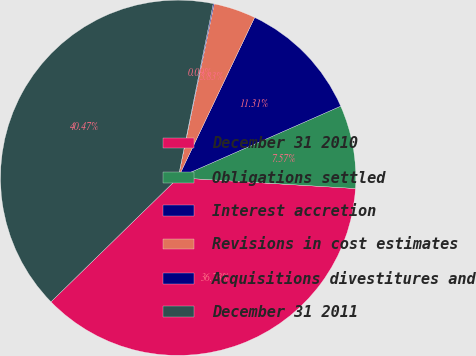<chart> <loc_0><loc_0><loc_500><loc_500><pie_chart><fcel>December 31 2010<fcel>Obligations settled<fcel>Interest accretion<fcel>Revisions in cost estimates<fcel>Acquisitions divestitures and<fcel>December 31 2011<nl><fcel>36.74%<fcel>7.57%<fcel>11.31%<fcel>3.83%<fcel>0.09%<fcel>40.48%<nl></chart> 